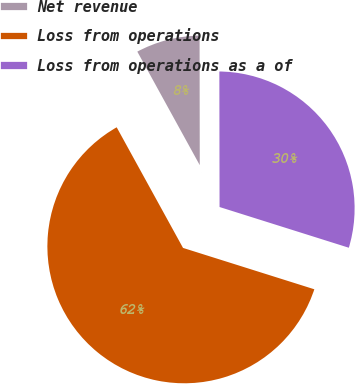Convert chart to OTSL. <chart><loc_0><loc_0><loc_500><loc_500><pie_chart><fcel>Net revenue<fcel>Loss from operations<fcel>Loss from operations as a of<nl><fcel>7.98%<fcel>62.14%<fcel>29.88%<nl></chart> 